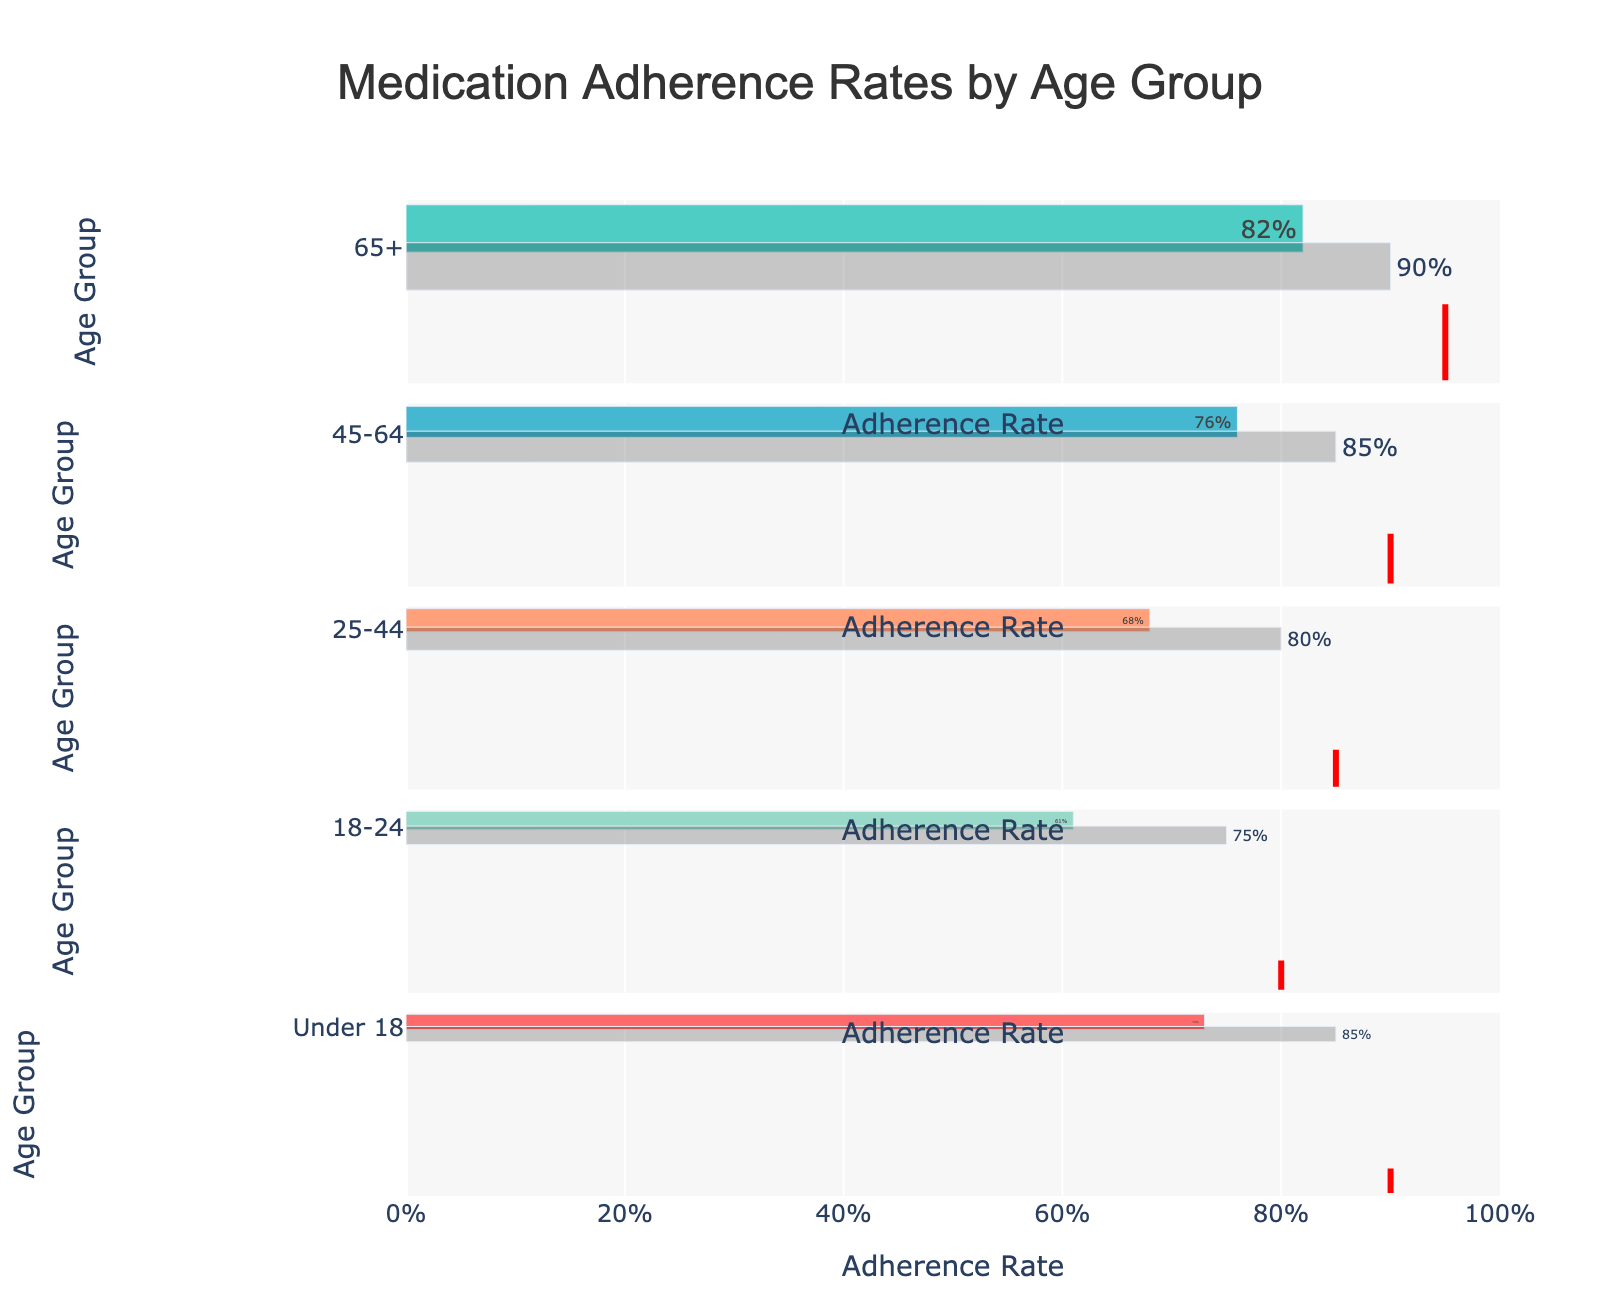What's the actual adherence rate for the 65+ age group? The bar plot for the 65+ age group shows the actual adherence rate, indicated by the brown bar and the value inside it.
Answer: 82% What is the comparative measure for the 18-24 age group? The red vertical line for the 18-24 age group indicates the comparative measure.
Answer: 80% Which age group has the largest gap between the actual and target adherence rates? By visual comparison, the 18-24 age group has the largest gap where the actual rate is 61% and the target rate is 75%, resulting in a 14% gap.
Answer: 18-24 How does the actual adherence rate of the 45-64 age group compare to its target adherence rate? The 45-64 group has an actual adherence rate of 76% and a target of 85%. The difference is a 9% shortfall from the target.
Answer: 9% shortfall Which age groups did not meet their comparative measure? Visual inspection of the red vertical lines shows that age groups 65+, 45-64, 25-44, and 18-24 have actual rates below their comparative measures.
Answer: 65+, 45-64, 25-44, 18-24 What is the overall trend in adherence rates as age decreases from 65+ to under 18? Observing the bars from top to bottom, the adherence rates seem to generally decrease as the age group gets younger, except for the under 18 group which has a higher adherence rate than the 25-44 and 18-24 groups.
Answer: General decrease with exception Among the age groups, which one has the highest adherence rate compared to its target? The 65+ age group has an actual adherence rate of 82% compared to their target of 90%, which is the highest adherence rate even though it's below the target.
Answer: 65+ What percentage value represents the target adherence for the 25-44 age group? The bar plot for the 25-44 age group shows the target adherence rate, mentioned on the bar outside.
Answer: 80% How many age groups have their actual adherence rates below 70%? The age groups 25-44 and 18-24 have actual adherence rates of 68% and 61%, respectively, each below 70%.
Answer: 2 What is the average actual adherence rate across all age groups? Summing the actual adherence rates (82, 76, 68, 61, 73) and dividing by 5 results in an average rate. (82+76+68+61+73)/5 = 72%
Answer: 72% 